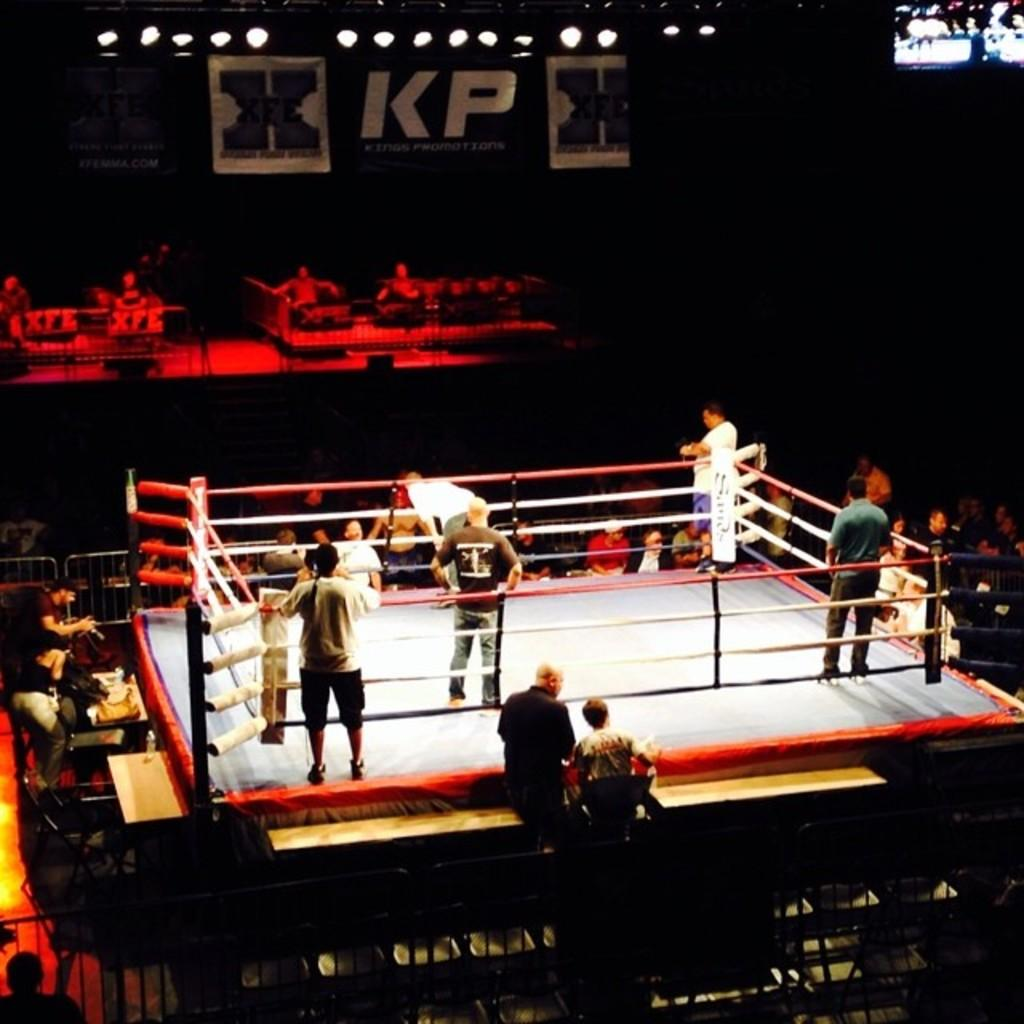<image>
Give a short and clear explanation of the subsequent image. Men are standing in and around a boxing rink with the letters KP above them. 